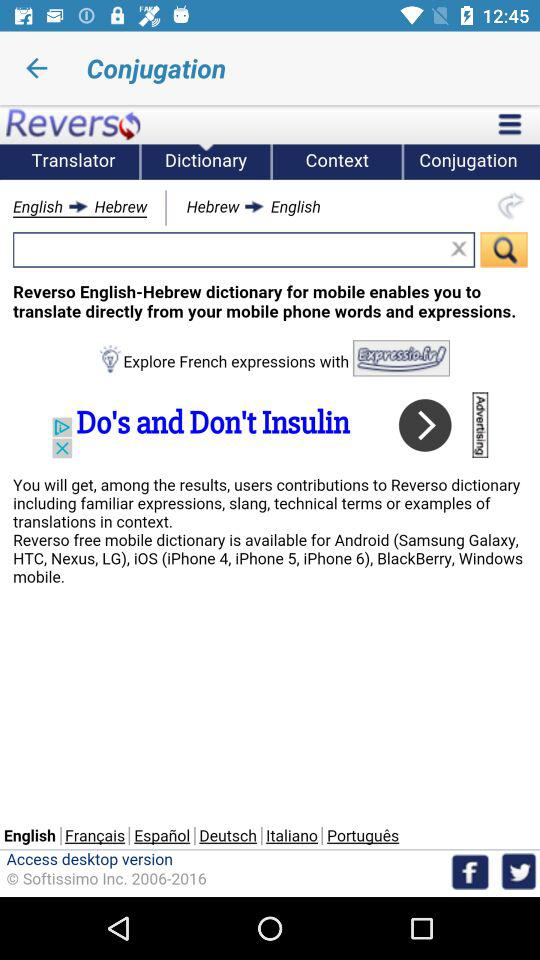What are the other languages that can be used? The other languages that can be used are Français, Español, Deutsch, Italiano and Português. 